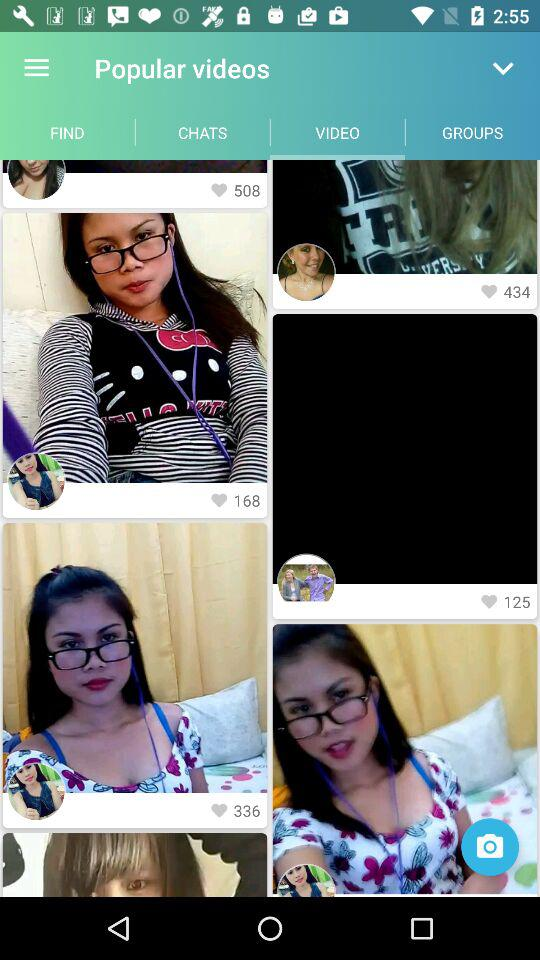How many comments are there?
When the provided information is insufficient, respond with <no answer>. <no answer> 